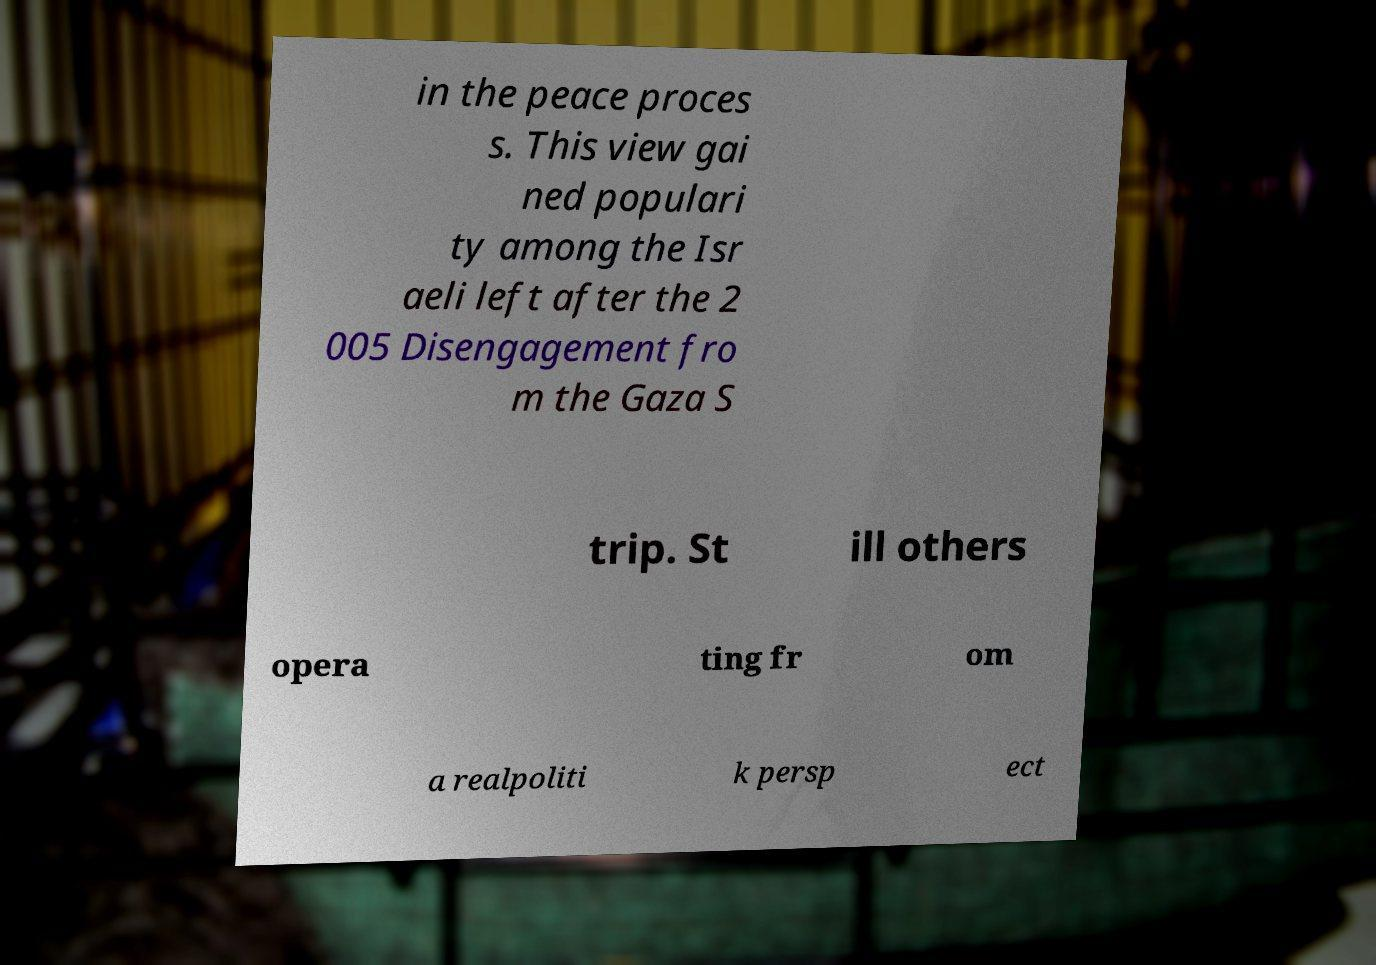Could you assist in decoding the text presented in this image and type it out clearly? in the peace proces s. This view gai ned populari ty among the Isr aeli left after the 2 005 Disengagement fro m the Gaza S trip. St ill others opera ting fr om a realpoliti k persp ect 